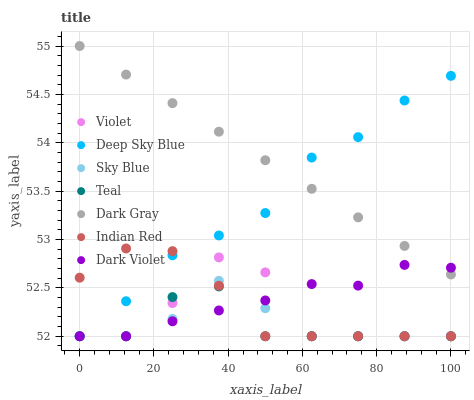Does Teal have the minimum area under the curve?
Answer yes or no. Yes. Does Dark Gray have the maximum area under the curve?
Answer yes or no. Yes. Does Violet have the minimum area under the curve?
Answer yes or no. No. Does Violet have the maximum area under the curve?
Answer yes or no. No. Is Dark Gray the smoothest?
Answer yes or no. Yes. Is Violet the roughest?
Answer yes or no. Yes. Is Dark Violet the smoothest?
Answer yes or no. No. Is Dark Violet the roughest?
Answer yes or no. No. Does Teal have the lowest value?
Answer yes or no. Yes. Does Dark Gray have the lowest value?
Answer yes or no. No. Does Dark Gray have the highest value?
Answer yes or no. Yes. Does Violet have the highest value?
Answer yes or no. No. Is Indian Red less than Dark Gray?
Answer yes or no. Yes. Is Dark Gray greater than Indian Red?
Answer yes or no. Yes. Does Deep Sky Blue intersect Violet?
Answer yes or no. Yes. Is Deep Sky Blue less than Violet?
Answer yes or no. No. Is Deep Sky Blue greater than Violet?
Answer yes or no. No. Does Indian Red intersect Dark Gray?
Answer yes or no. No. 